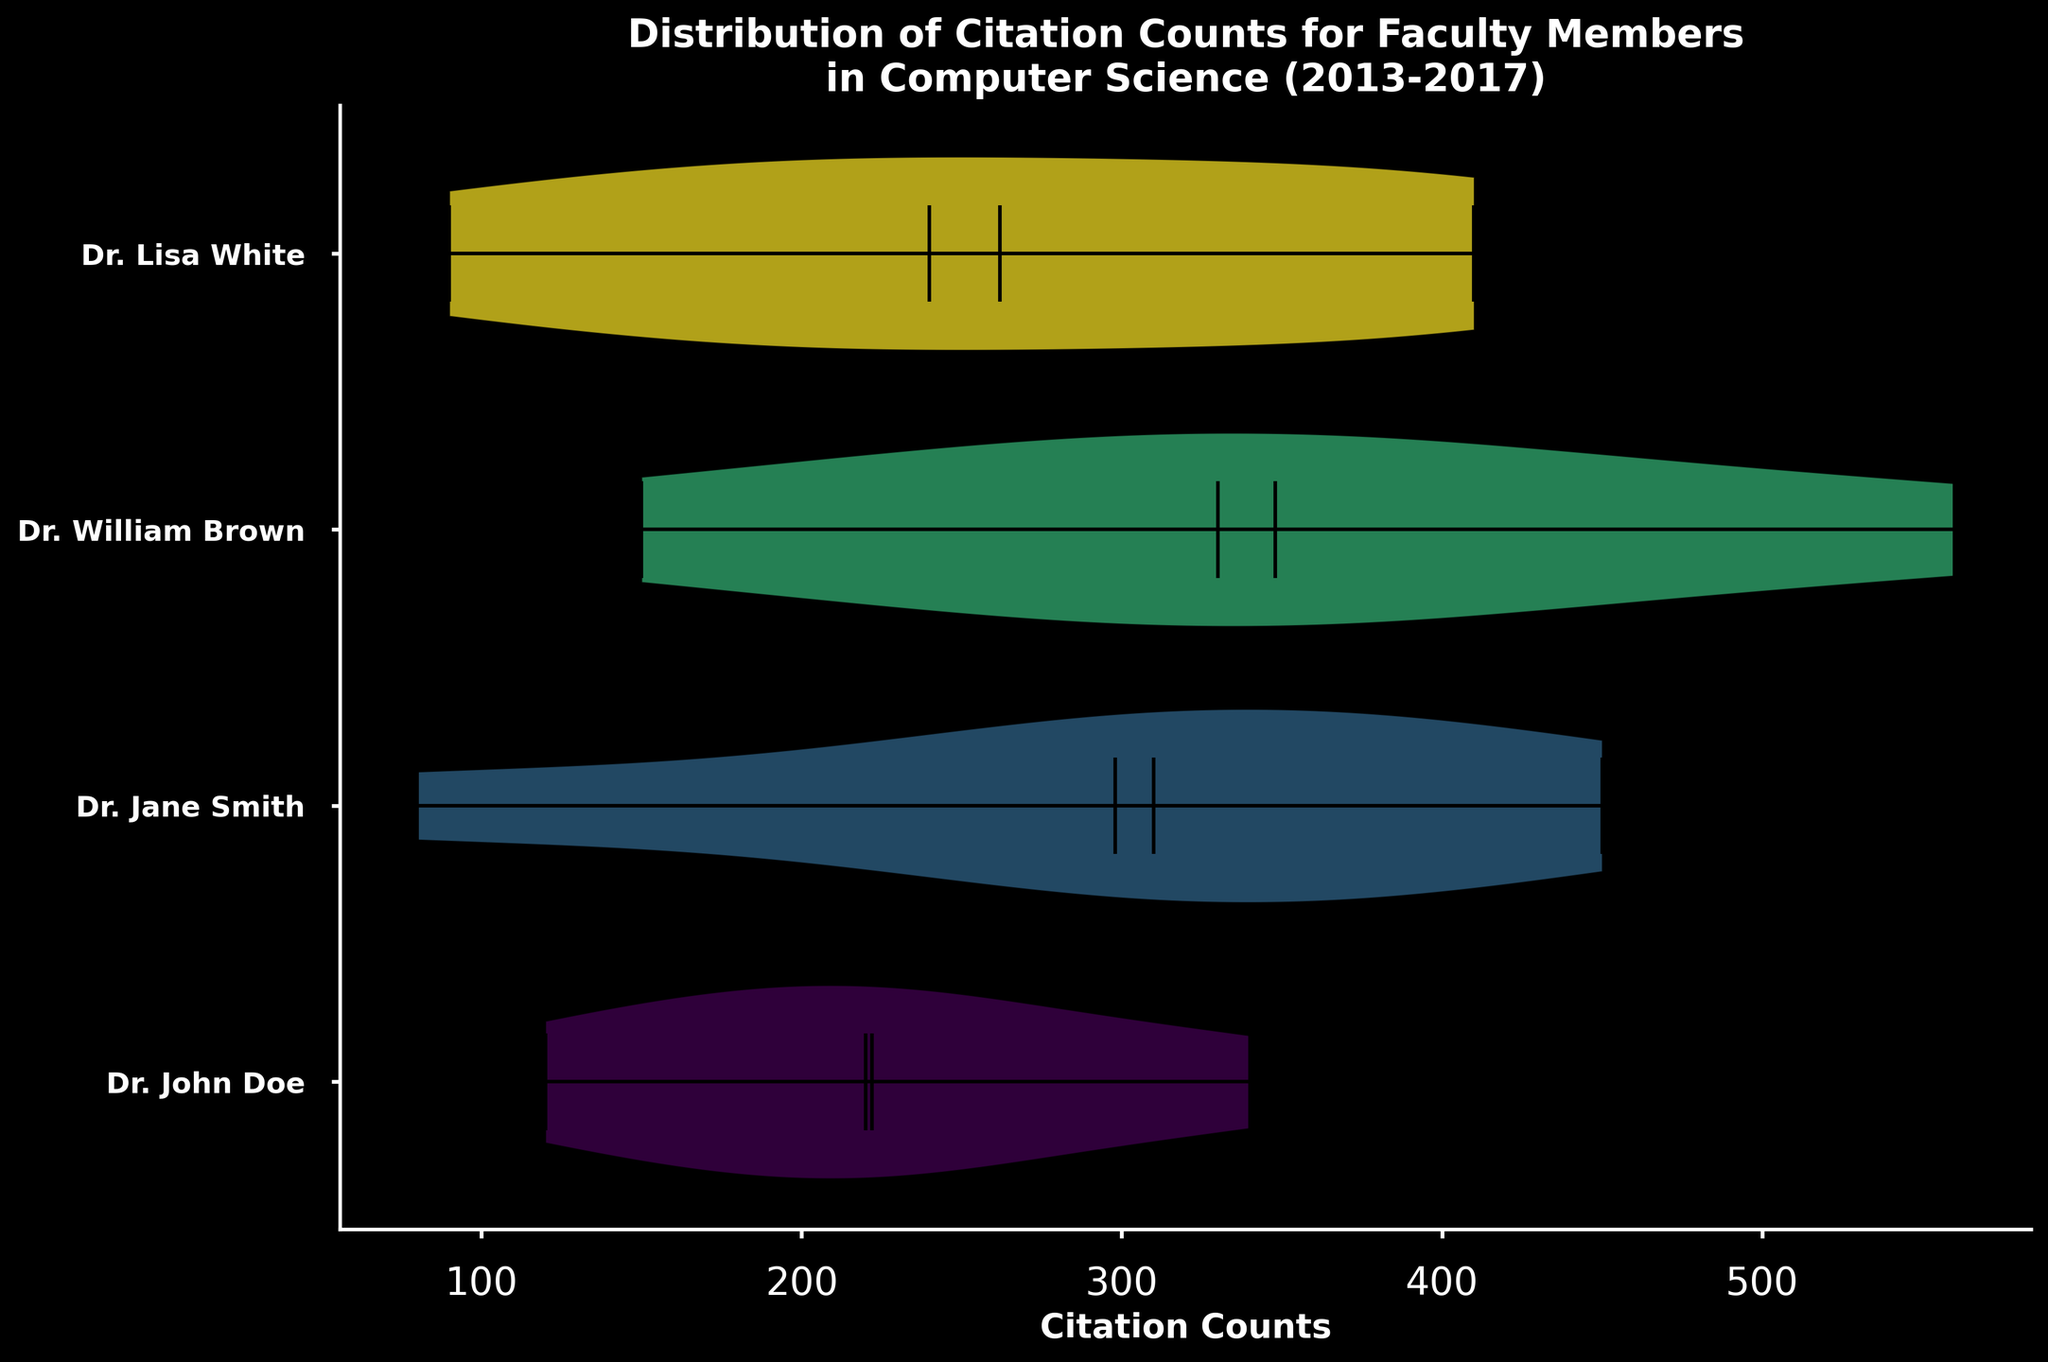What is the title of the figure? The title is located at the top of the horizontal violin chart. It states: "Distribution of Citation Counts for Faculty Members in Computer Science (2013-2017).”
Answer: Distribution of Citation Counts for Faculty Members in Computer Science (2013-2017) Which faculty member has the widest distribution of citation counts? The width of the violins in the chart indicates the distribution. The widest distribution is observed for Dr. William Brown, suggesting a highly variable citation count range.
Answer: Dr. William Brown How many faculty members are represented in the chart? Each violin plot corresponds to a different faculty member. By counting these plots along the y-axis, we can see that there are four faculty members: Dr. John Doe, Dr. Jane Smith, Dr. William Brown, and Dr. Lisa White.
Answer: Four Which faculty member has the highest median citation count? The median value is represented by a horizontal line within each violin plot. The highest median can be found by comparing these lines across the plots. Dr. Lisa White has the highest median citation count.
Answer: Dr. Lisa White What is the median citation count for Dr. John Doe? The median citation count is shown by the horizontal line within the violin plot. For Dr. John Doe, this median line falls close to the value indicated on the x-axis of the chart, which appears to be around 220.
Answer: 220 Who has a higher average citation count, Dr. Jane Smith or Dr. John Doe? The average citation count can be roughly estimated from the means indicated by dot markers in the violin plots. Dr. Jane Smith's average is higher than Dr. John Doe's as her dot marker is positioned relatively higher on the x-axis.
Answer: Dr. Jane Smith Which ranges of citation counts are most frequently cited for Dr. Lisa White? The width of the violin plot indicates the density of citation counts. For Dr. Lisa White, the violin plot is widest around the range 370-410, indicating these citation counts are most frequent.
Answer: 370-410 Compare the mean citation counts of Dr. William Brown and Dr. Lisa White. The mean values are indicated by a dot in the violin plots. Dr. William Brown’s mean is around 350, whereas Dr. Lisa White’s mean is higher, around 340. This suggests that Dr. Lisa White has a slightly higher mean citation count than Dr. William Brown.
Answer: Dr. Lisa White Do any of the faculty members have citation counts with similar distributions? By comparing the shapes and widths of the violin plots, it's clear that Dr. Jane Smith and Dr. William Brown have similar broad and wide distributions, suggesting similar variabilities in their citation counts.
Answer: Dr. Jane Smith and Dr. William Brown 